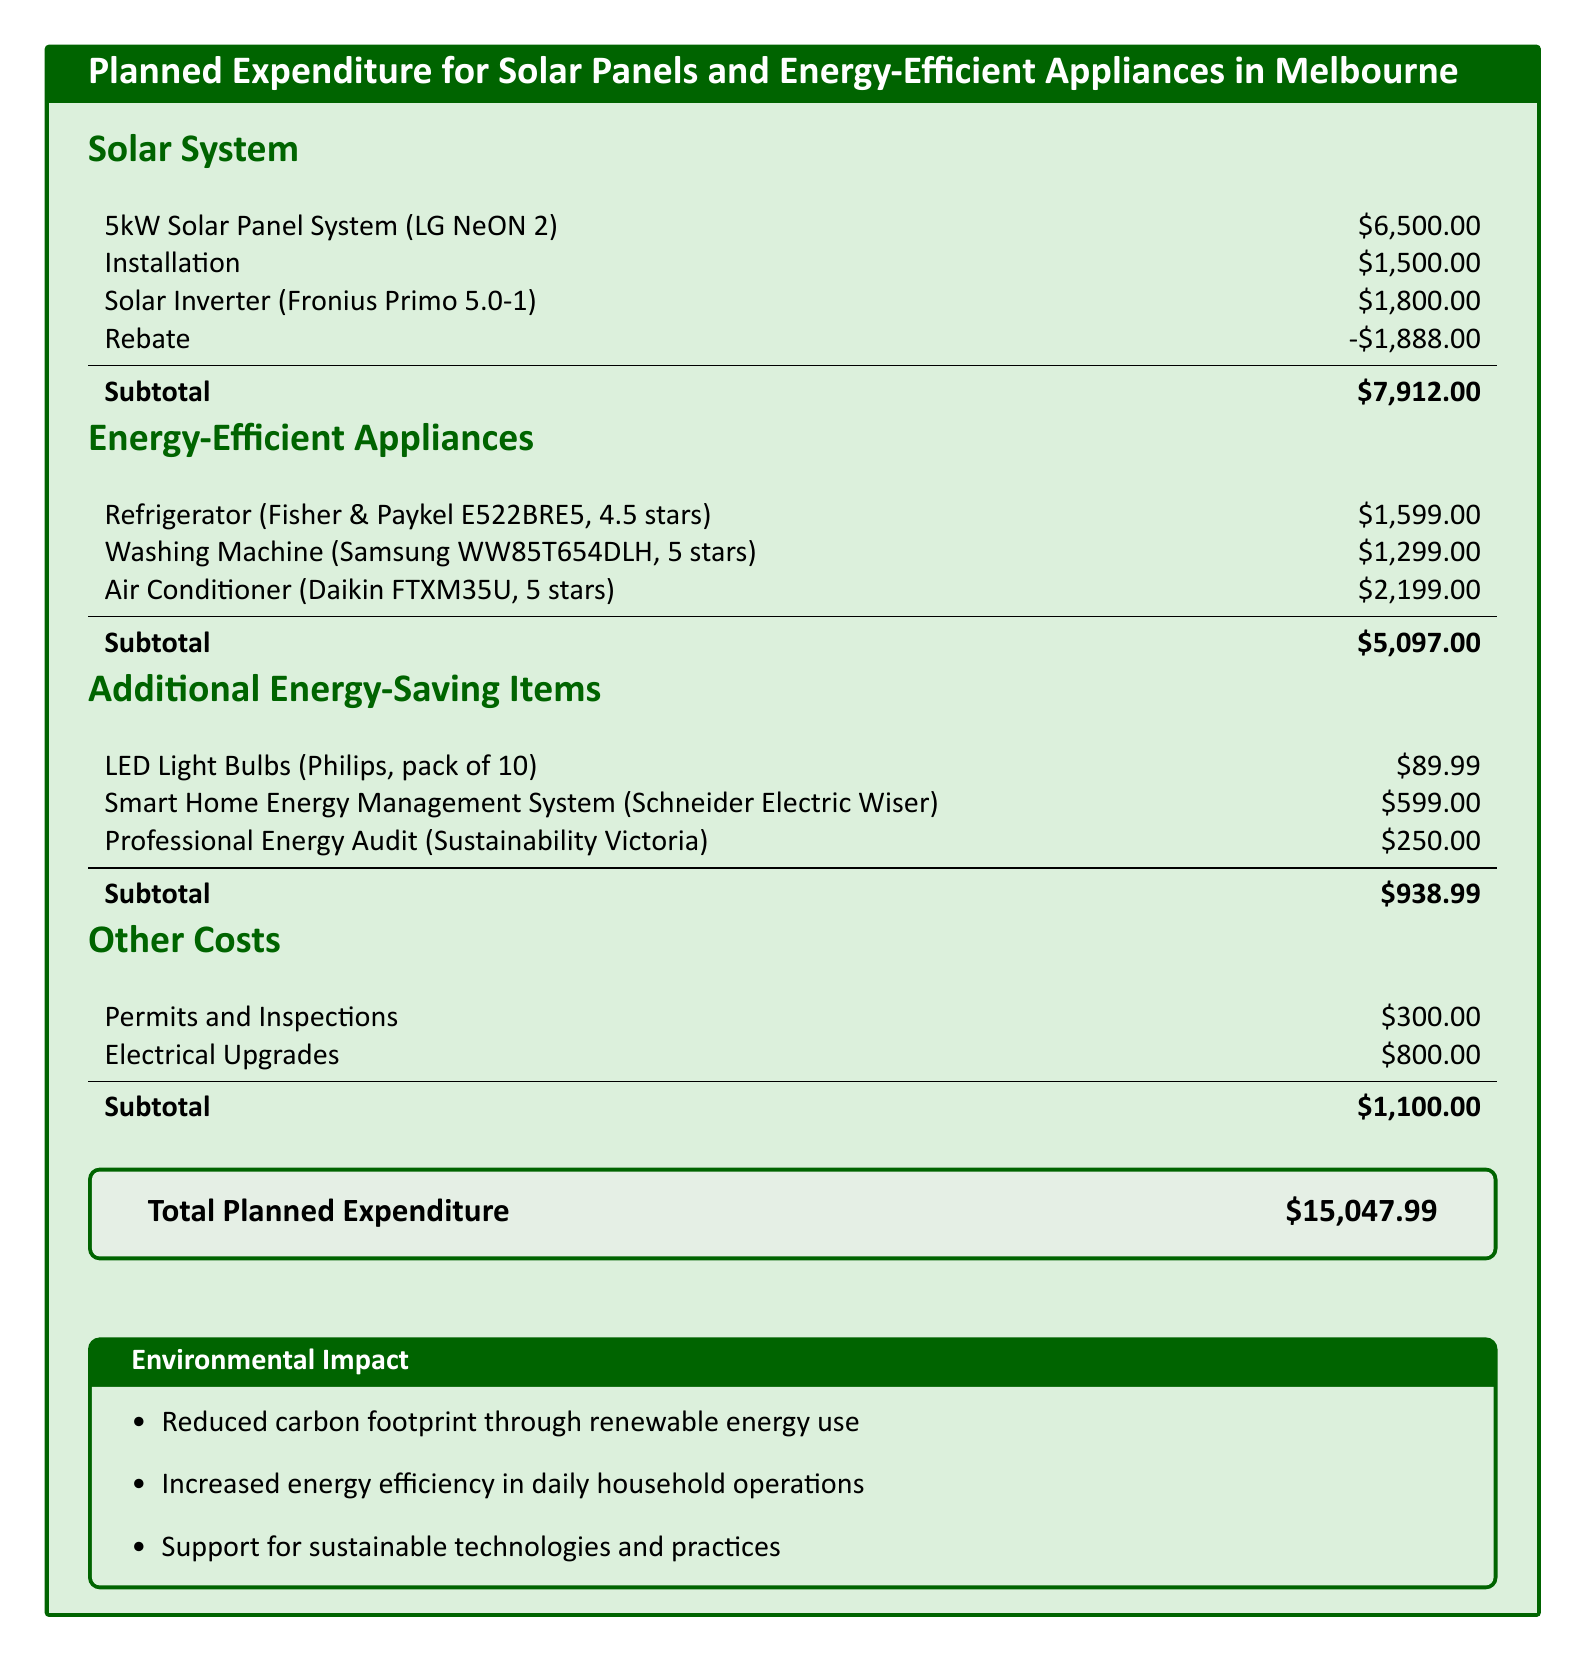What is the total planned expenditure? The total planned expenditure is aggregated from all sections of planned spending, which amounts to $15,047.99.
Answer: $15,047.99 What is the cost of the solar inverter? The cost listed for the solar inverter is found in the Solar System section, which is $1,800.00.
Answer: $1,800.00 How much is saved from the solar panel rebate? The rebate mentioned in the Solar System section indicates a reduction of $1,888.00 from the total solar expenditure.
Answer: $1,888.00 What is the price of the energy-efficient air conditioner? The air conditioner's cost is stated as $2,199.00 in the Energy-Efficient Appliances section.
Answer: $2,199.00 What is included in the additional energy-saving items? The additional energy-saving items listed include LED light bulbs, a smart home energy management system, and a professional energy audit.
Answer: LED light bulbs, smart home energy management system, and professional energy audit What are the two types of costs listed in the Other Costs section? The Other Costs section specifies costs related to permits and inspections, and electrical upgrades.
Answer: Permits and inspections, electrical upgrades What is the subtotal for energy-efficient appliances? The subtotal calculated for energy-efficient appliances is detailed in the Energy-Efficient Appliances section and is $5,097.00.
Answer: $5,097.00 How many LED light bulbs are in the package? The package of LED light bulbs contains 10 bulbs as stated in the Additional Energy-Saving Items section.
Answer: 10 What are the reasons for installation cost? The installation cost is representative of the labor and service provided for installing the solar panel system.
Answer: Labor and service for installing the solar panel system 